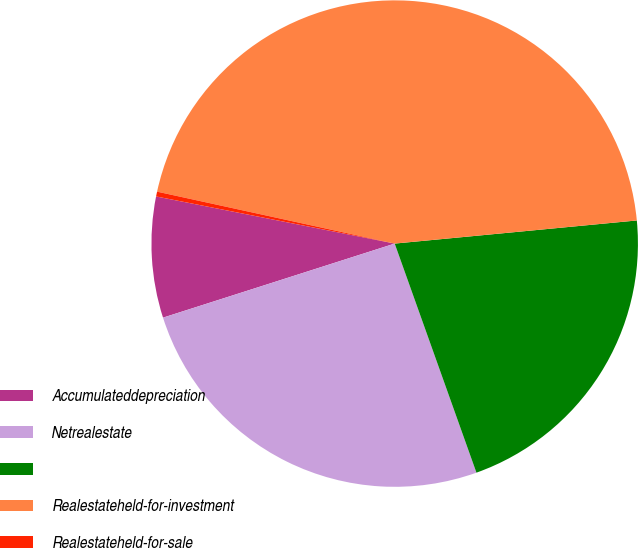<chart> <loc_0><loc_0><loc_500><loc_500><pie_chart><fcel>Accumulateddepreciation<fcel>Netrealestate<fcel>Unnamed: 2<fcel>Realestateheld-for-investment<fcel>Realestateheld-for-sale<nl><fcel>8.03%<fcel>25.53%<fcel>21.06%<fcel>45.06%<fcel>0.32%<nl></chart> 